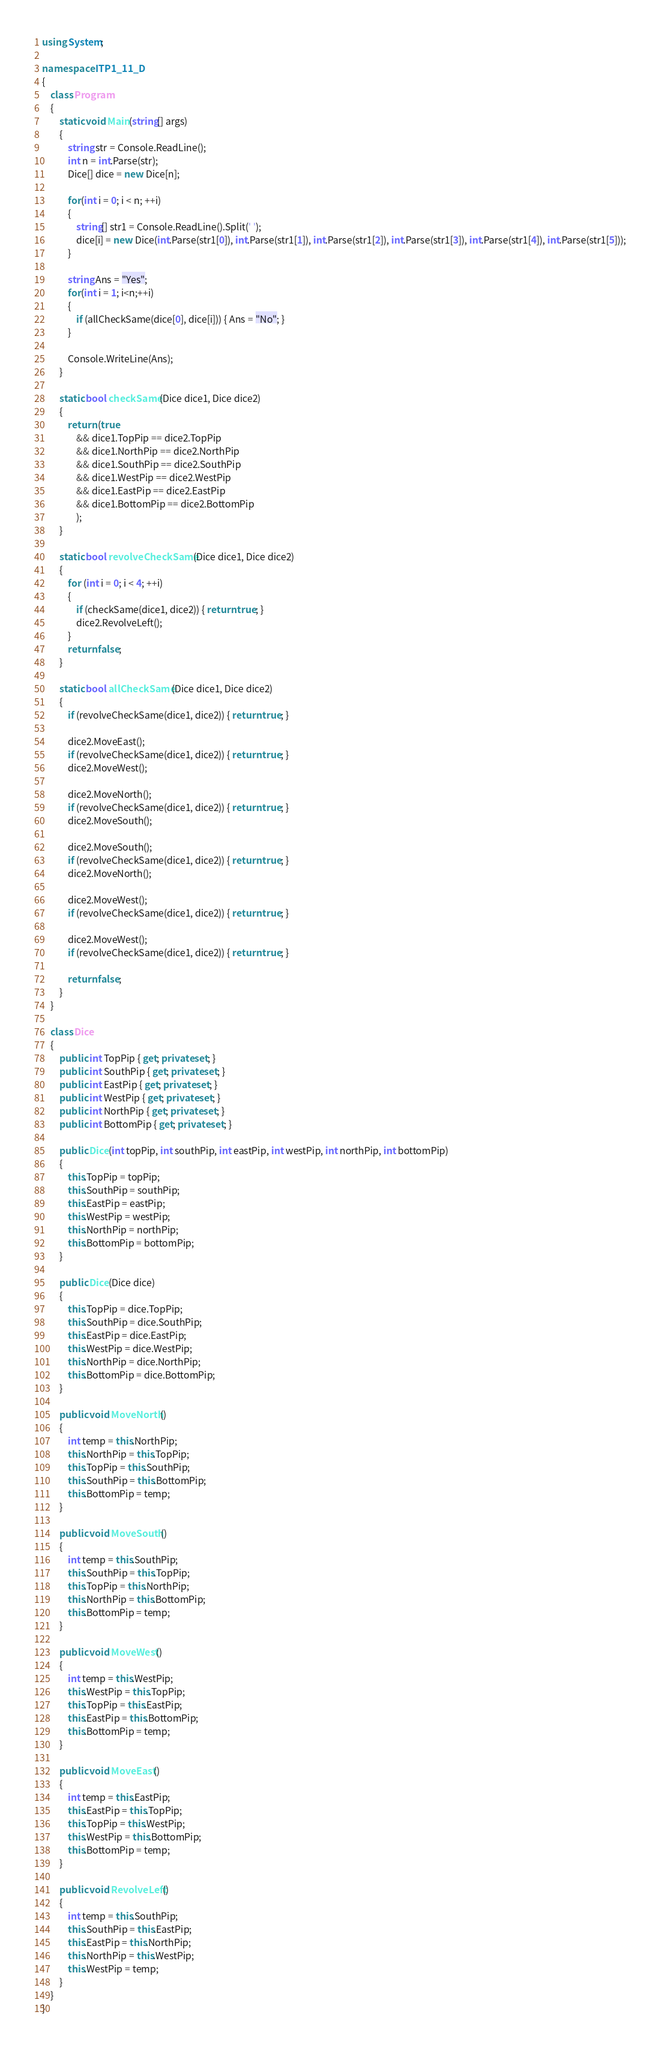<code> <loc_0><loc_0><loc_500><loc_500><_C#_>using System;

namespace ITP1_11_D
{
    class Program
    {
        static void Main(string[] args)
        {
            string str = Console.ReadLine();
            int n = int.Parse(str);
            Dice[] dice = new Dice[n];

            for(int i = 0; i < n; ++i)
            {
                string[] str1 = Console.ReadLine().Split(' ');
                dice[i] = new Dice(int.Parse(str1[0]), int.Parse(str1[1]), int.Parse(str1[2]), int.Parse(str1[3]), int.Parse(str1[4]), int.Parse(str1[5]));
            }

            string Ans = "Yes";
            for(int i = 1; i<n;++i)
            {
                if (allCheckSame(dice[0], dice[i])) { Ans = "No"; }
            }

            Console.WriteLine(Ans); 
        }

        static bool checkSame(Dice dice1, Dice dice2)
        {
            return (true
                && dice1.TopPip == dice2.TopPip
                && dice1.NorthPip == dice2.NorthPip
                && dice1.SouthPip == dice2.SouthPip
                && dice1.WestPip == dice2.WestPip
                && dice1.EastPip == dice2.EastPip
                && dice1.BottomPip == dice2.BottomPip
                );
        }

        static bool revolveCheckSame(Dice dice1, Dice dice2)
        {
            for (int i = 0; i < 4; ++i)
            {
                if (checkSame(dice1, dice2)) { return true; }
                dice2.RevolveLeft();
            }
            return false;
        }

        static bool allCheckSame(Dice dice1, Dice dice2)
        {
            if (revolveCheckSame(dice1, dice2)) { return true; }

            dice2.MoveEast();
            if (revolveCheckSame(dice1, dice2)) { return true; }
            dice2.MoveWest();

            dice2.MoveNorth();
            if (revolveCheckSame(dice1, dice2)) { return true; }
            dice2.MoveSouth();

            dice2.MoveSouth();
            if (revolveCheckSame(dice1, dice2)) { return true; }
            dice2.MoveNorth();

            dice2.MoveWest();
            if (revolveCheckSame(dice1, dice2)) { return true; }

            dice2.MoveWest();
            if (revolveCheckSame(dice1, dice2)) { return true; }

            return false;
        }
    }

    class Dice
    {
        public int TopPip { get; private set; }
        public int SouthPip { get; private set; }
        public int EastPip { get; private set; }
        public int WestPip { get; private set; }
        public int NorthPip { get; private set; }
        public int BottomPip { get; private set; }

        public Dice(int topPip, int southPip, int eastPip, int westPip, int northPip, int bottomPip)
        {
            this.TopPip = topPip;
            this.SouthPip = southPip;
            this.EastPip = eastPip;
            this.WestPip = westPip;
            this.NorthPip = northPip;
            this.BottomPip = bottomPip;
        }

        public Dice(Dice dice)
        {
            this.TopPip = dice.TopPip;
            this.SouthPip = dice.SouthPip;
            this.EastPip = dice.EastPip;
            this.WestPip = dice.WestPip;
            this.NorthPip = dice.NorthPip;
            this.BottomPip = dice.BottomPip;
        }

        public void MoveNorth()
        {
            int temp = this.NorthPip;
            this.NorthPip = this.TopPip;
            this.TopPip = this.SouthPip;
            this.SouthPip = this.BottomPip;
            this.BottomPip = temp;
        }

        public void MoveSouth()
        {
            int temp = this.SouthPip;
            this.SouthPip = this.TopPip;
            this.TopPip = this.NorthPip;
            this.NorthPip = this.BottomPip;
            this.BottomPip = temp;
        }

        public void MoveWest()
        {
            int temp = this.WestPip;
            this.WestPip = this.TopPip;
            this.TopPip = this.EastPip;
            this.EastPip = this.BottomPip;
            this.BottomPip = temp;
        }

        public void MoveEast()
        {
            int temp = this.EastPip;
            this.EastPip = this.TopPip;
            this.TopPip = this.WestPip;
            this.WestPip = this.BottomPip;
            this.BottomPip = temp;
        }

        public void RevolveLeft()
        {
            int temp = this.SouthPip;
            this.SouthPip = this.EastPip;
            this.EastPip = this.NorthPip;
            this.NorthPip = this.WestPip;
            this.WestPip = temp;
        }
    }
}</code> 